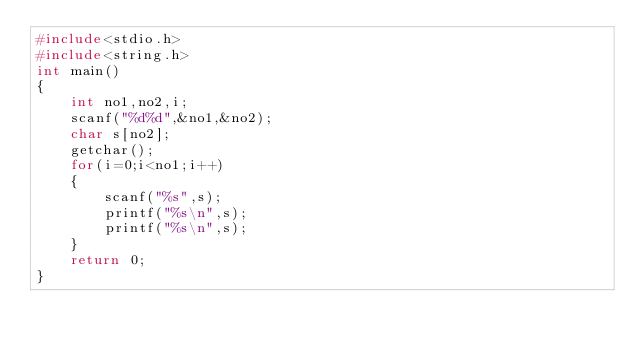<code> <loc_0><loc_0><loc_500><loc_500><_C_>#include<stdio.h>
#include<string.h>
int main()
{
    int no1,no2,i;
    scanf("%d%d",&no1,&no2);
    char s[no2];
    getchar();
    for(i=0;i<no1;i++)
    {
        scanf("%s",s);
        printf("%s\n",s);
        printf("%s\n",s);
    }
    return 0;
}
</code> 